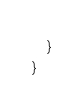<code> <loc_0><loc_0><loc_500><loc_500><_Kotlin_>    }
}
</code> 